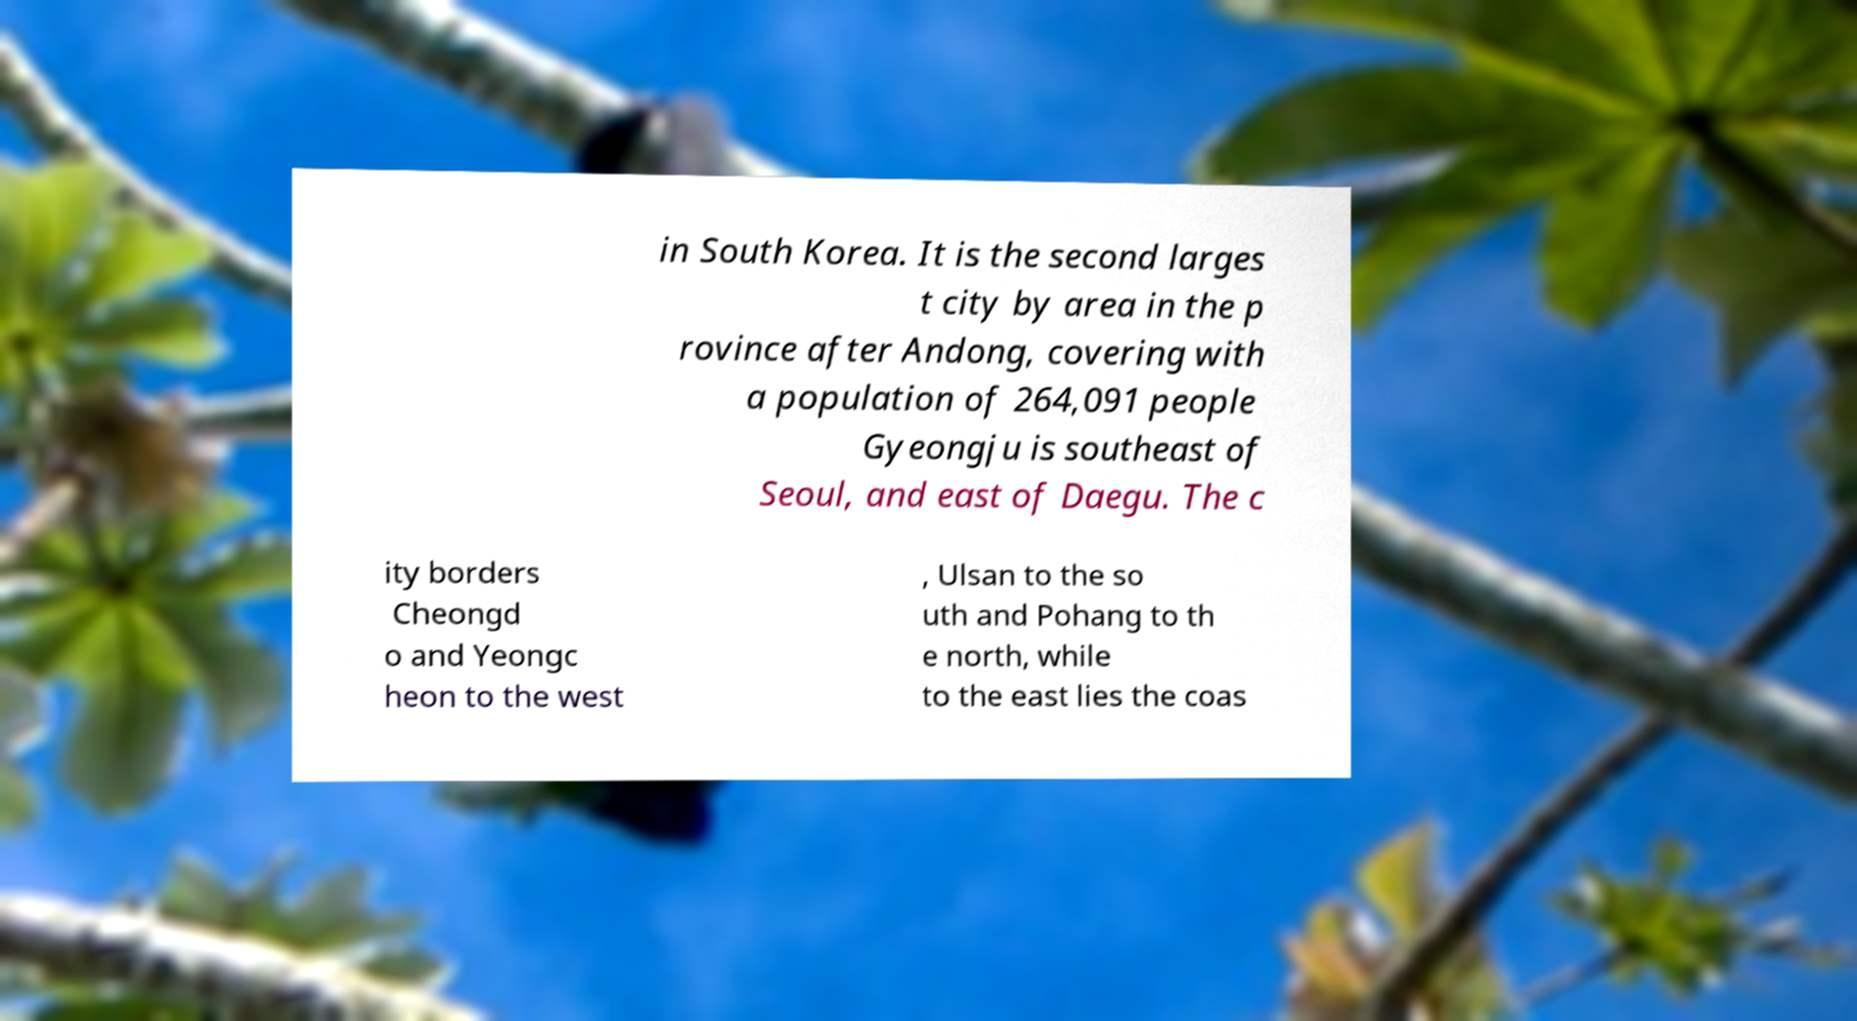Can you accurately transcribe the text from the provided image for me? in South Korea. It is the second larges t city by area in the p rovince after Andong, covering with a population of 264,091 people Gyeongju is southeast of Seoul, and east of Daegu. The c ity borders Cheongd o and Yeongc heon to the west , Ulsan to the so uth and Pohang to th e north, while to the east lies the coas 